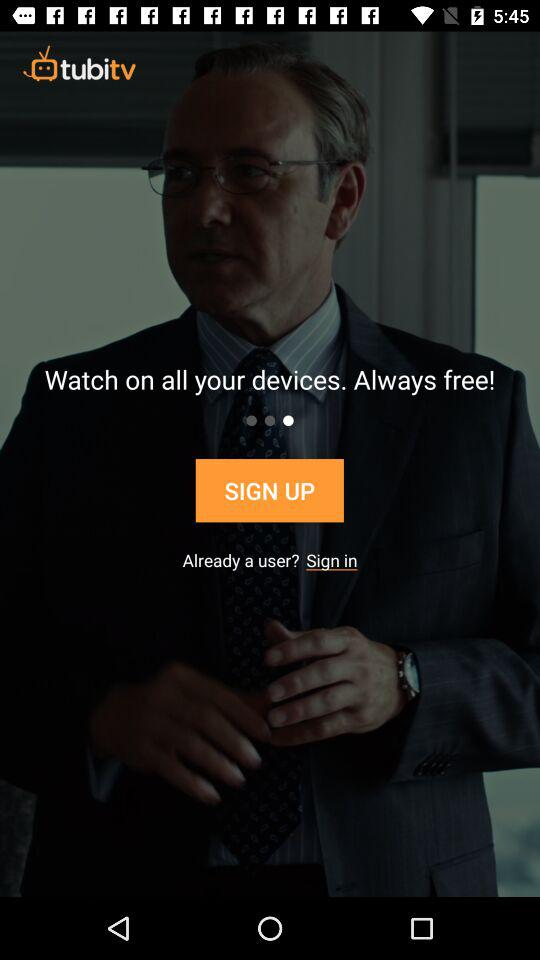What is the name of the application? The application name is "tubitv". 